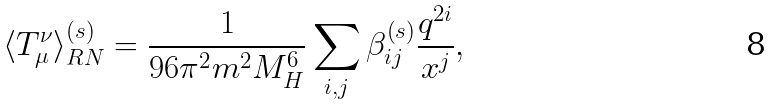<formula> <loc_0><loc_0><loc_500><loc_500>\langle T _ { \mu } ^ { \nu } \rangle _ { R N } ^ { \left ( s \right ) } = \frac { 1 } { 9 6 \pi ^ { 2 } m ^ { 2 } M _ { H } ^ { 6 } } \sum _ { i , j } \beta _ { i j } ^ { \left ( s \right ) } \frac { q ^ { 2 i } } { x ^ { j } } ,</formula> 